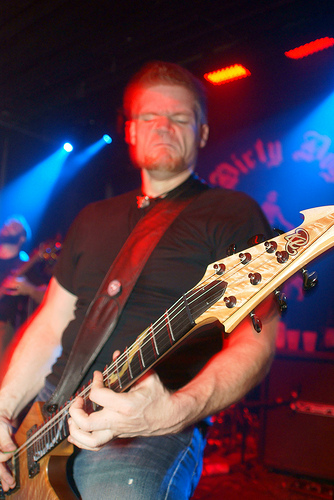<image>
Can you confirm if the guitar is next to the man? No. The guitar is not positioned next to the man. They are located in different areas of the scene. Where is the poster in relation to the guitarist? Is it in front of the guitarist? No. The poster is not in front of the guitarist. The spatial positioning shows a different relationship between these objects. 